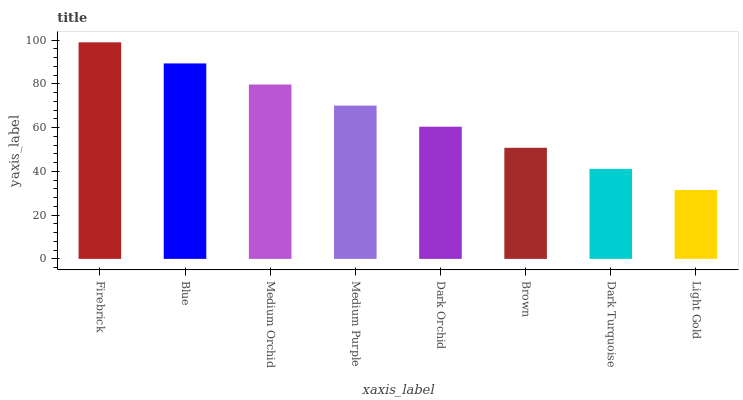Is Light Gold the minimum?
Answer yes or no. Yes. Is Firebrick the maximum?
Answer yes or no. Yes. Is Blue the minimum?
Answer yes or no. No. Is Blue the maximum?
Answer yes or no. No. Is Firebrick greater than Blue?
Answer yes or no. Yes. Is Blue less than Firebrick?
Answer yes or no. Yes. Is Blue greater than Firebrick?
Answer yes or no. No. Is Firebrick less than Blue?
Answer yes or no. No. Is Medium Purple the high median?
Answer yes or no. Yes. Is Dark Orchid the low median?
Answer yes or no. Yes. Is Medium Orchid the high median?
Answer yes or no. No. Is Firebrick the low median?
Answer yes or no. No. 